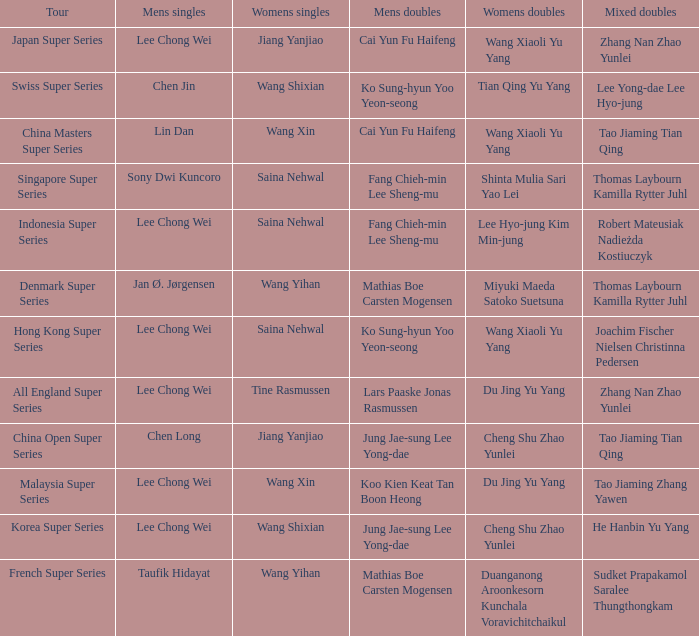Who were the womens doubles when the mixed doubles were zhang nan zhao yunlei on the tour all england super series? Du Jing Yu Yang. 